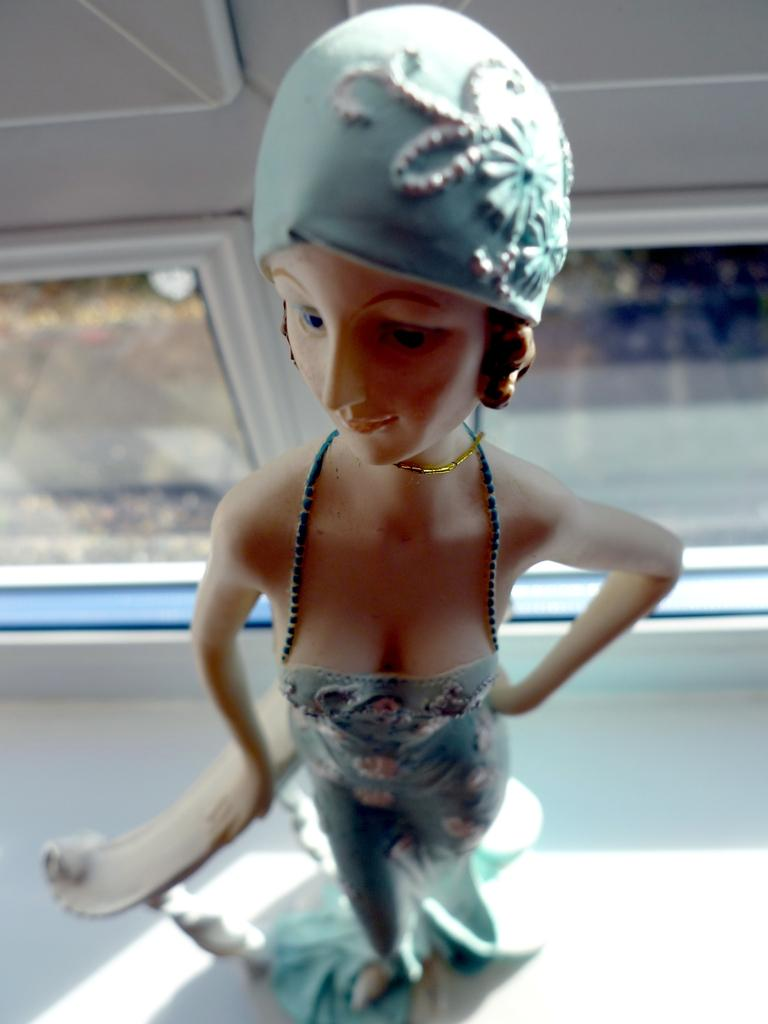What is the main subject of the image? There is a doll in the image. Can you describe the background of the image? The background of the image is blurred. What type of copper material is used to make the doll's hair in the image? There is no mention of copper or any specific material used for the doll's hair in the image. 